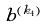Convert formula to latex. <formula><loc_0><loc_0><loc_500><loc_500>b ^ { ( k _ { 4 } ) }</formula> 